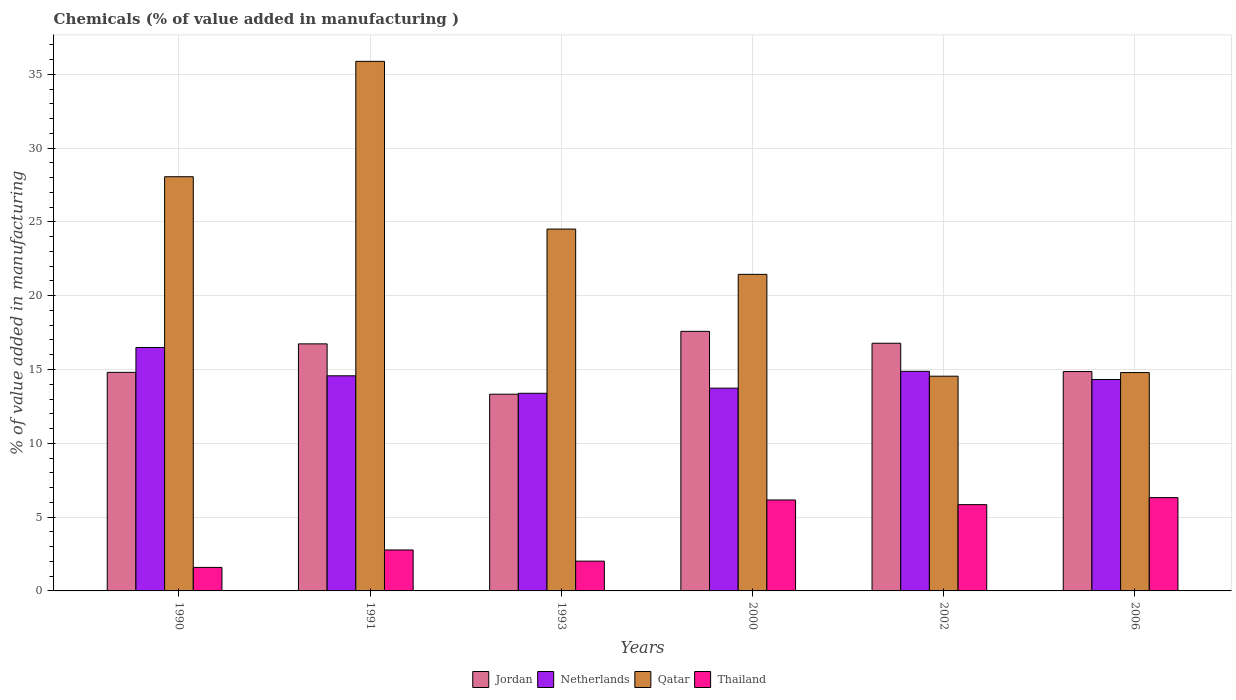How many different coloured bars are there?
Make the answer very short. 4. Are the number of bars per tick equal to the number of legend labels?
Provide a succinct answer. Yes. Are the number of bars on each tick of the X-axis equal?
Provide a succinct answer. Yes. How many bars are there on the 5th tick from the left?
Give a very brief answer. 4. What is the label of the 6th group of bars from the left?
Give a very brief answer. 2006. In how many cases, is the number of bars for a given year not equal to the number of legend labels?
Ensure brevity in your answer.  0. What is the value added in manufacturing chemicals in Netherlands in 1993?
Make the answer very short. 13.39. Across all years, what is the maximum value added in manufacturing chemicals in Jordan?
Offer a terse response. 17.58. Across all years, what is the minimum value added in manufacturing chemicals in Qatar?
Give a very brief answer. 14.55. In which year was the value added in manufacturing chemicals in Qatar minimum?
Provide a short and direct response. 2002. What is the total value added in manufacturing chemicals in Jordan in the graph?
Keep it short and to the point. 94.09. What is the difference between the value added in manufacturing chemicals in Thailand in 1991 and that in 2000?
Offer a very short reply. -3.39. What is the difference between the value added in manufacturing chemicals in Thailand in 1993 and the value added in manufacturing chemicals in Netherlands in 2002?
Give a very brief answer. -12.86. What is the average value added in manufacturing chemicals in Qatar per year?
Keep it short and to the point. 23.21. In the year 2002, what is the difference between the value added in manufacturing chemicals in Thailand and value added in manufacturing chemicals in Jordan?
Make the answer very short. -10.93. What is the ratio of the value added in manufacturing chemicals in Netherlands in 1991 to that in 1993?
Ensure brevity in your answer.  1.09. Is the difference between the value added in manufacturing chemicals in Thailand in 1990 and 2002 greater than the difference between the value added in manufacturing chemicals in Jordan in 1990 and 2002?
Your response must be concise. No. What is the difference between the highest and the second highest value added in manufacturing chemicals in Jordan?
Offer a terse response. 0.81. What is the difference between the highest and the lowest value added in manufacturing chemicals in Thailand?
Provide a short and direct response. 4.73. What does the 4th bar from the left in 2006 represents?
Your response must be concise. Thailand. What does the 2nd bar from the right in 2002 represents?
Provide a succinct answer. Qatar. Is it the case that in every year, the sum of the value added in manufacturing chemicals in Netherlands and value added in manufacturing chemicals in Jordan is greater than the value added in manufacturing chemicals in Thailand?
Ensure brevity in your answer.  Yes. How many years are there in the graph?
Your answer should be very brief. 6. What is the difference between two consecutive major ticks on the Y-axis?
Keep it short and to the point. 5. Are the values on the major ticks of Y-axis written in scientific E-notation?
Give a very brief answer. No. Where does the legend appear in the graph?
Your response must be concise. Bottom center. How many legend labels are there?
Provide a succinct answer. 4. How are the legend labels stacked?
Give a very brief answer. Horizontal. What is the title of the graph?
Give a very brief answer. Chemicals (% of value added in manufacturing ). Does "Mauritius" appear as one of the legend labels in the graph?
Offer a very short reply. No. What is the label or title of the Y-axis?
Provide a succinct answer. % of value added in manufacturing. What is the % of value added in manufacturing in Jordan in 1990?
Your answer should be very brief. 14.81. What is the % of value added in manufacturing in Netherlands in 1990?
Keep it short and to the point. 16.49. What is the % of value added in manufacturing of Qatar in 1990?
Provide a short and direct response. 28.06. What is the % of value added in manufacturing of Thailand in 1990?
Give a very brief answer. 1.59. What is the % of value added in manufacturing of Jordan in 1991?
Your answer should be very brief. 16.74. What is the % of value added in manufacturing of Netherlands in 1991?
Make the answer very short. 14.57. What is the % of value added in manufacturing in Qatar in 1991?
Your answer should be very brief. 35.88. What is the % of value added in manufacturing in Thailand in 1991?
Offer a very short reply. 2.77. What is the % of value added in manufacturing of Jordan in 1993?
Keep it short and to the point. 13.33. What is the % of value added in manufacturing of Netherlands in 1993?
Offer a very short reply. 13.39. What is the % of value added in manufacturing of Qatar in 1993?
Offer a terse response. 24.51. What is the % of value added in manufacturing in Thailand in 1993?
Your answer should be compact. 2.02. What is the % of value added in manufacturing in Jordan in 2000?
Give a very brief answer. 17.58. What is the % of value added in manufacturing of Netherlands in 2000?
Your response must be concise. 13.74. What is the % of value added in manufacturing of Qatar in 2000?
Keep it short and to the point. 21.45. What is the % of value added in manufacturing of Thailand in 2000?
Your answer should be very brief. 6.16. What is the % of value added in manufacturing of Jordan in 2002?
Offer a very short reply. 16.78. What is the % of value added in manufacturing of Netherlands in 2002?
Offer a terse response. 14.88. What is the % of value added in manufacturing in Qatar in 2002?
Your answer should be very brief. 14.55. What is the % of value added in manufacturing of Thailand in 2002?
Give a very brief answer. 5.85. What is the % of value added in manufacturing in Jordan in 2006?
Give a very brief answer. 14.86. What is the % of value added in manufacturing in Netherlands in 2006?
Ensure brevity in your answer.  14.32. What is the % of value added in manufacturing in Qatar in 2006?
Your answer should be compact. 14.79. What is the % of value added in manufacturing in Thailand in 2006?
Ensure brevity in your answer.  6.32. Across all years, what is the maximum % of value added in manufacturing in Jordan?
Make the answer very short. 17.58. Across all years, what is the maximum % of value added in manufacturing in Netherlands?
Your response must be concise. 16.49. Across all years, what is the maximum % of value added in manufacturing in Qatar?
Offer a terse response. 35.88. Across all years, what is the maximum % of value added in manufacturing of Thailand?
Ensure brevity in your answer.  6.32. Across all years, what is the minimum % of value added in manufacturing in Jordan?
Give a very brief answer. 13.33. Across all years, what is the minimum % of value added in manufacturing of Netherlands?
Offer a very short reply. 13.39. Across all years, what is the minimum % of value added in manufacturing in Qatar?
Ensure brevity in your answer.  14.55. Across all years, what is the minimum % of value added in manufacturing in Thailand?
Give a very brief answer. 1.59. What is the total % of value added in manufacturing of Jordan in the graph?
Make the answer very short. 94.09. What is the total % of value added in manufacturing of Netherlands in the graph?
Provide a succinct answer. 87.39. What is the total % of value added in manufacturing of Qatar in the graph?
Give a very brief answer. 139.23. What is the total % of value added in manufacturing in Thailand in the graph?
Your answer should be compact. 24.71. What is the difference between the % of value added in manufacturing of Jordan in 1990 and that in 1991?
Your response must be concise. -1.93. What is the difference between the % of value added in manufacturing of Netherlands in 1990 and that in 1991?
Offer a terse response. 1.92. What is the difference between the % of value added in manufacturing in Qatar in 1990 and that in 1991?
Keep it short and to the point. -7.82. What is the difference between the % of value added in manufacturing of Thailand in 1990 and that in 1991?
Offer a terse response. -1.18. What is the difference between the % of value added in manufacturing of Jordan in 1990 and that in 1993?
Your answer should be very brief. 1.48. What is the difference between the % of value added in manufacturing of Netherlands in 1990 and that in 1993?
Provide a succinct answer. 3.1. What is the difference between the % of value added in manufacturing of Qatar in 1990 and that in 1993?
Give a very brief answer. 3.55. What is the difference between the % of value added in manufacturing of Thailand in 1990 and that in 1993?
Offer a terse response. -0.42. What is the difference between the % of value added in manufacturing in Jordan in 1990 and that in 2000?
Keep it short and to the point. -2.78. What is the difference between the % of value added in manufacturing of Netherlands in 1990 and that in 2000?
Keep it short and to the point. 2.75. What is the difference between the % of value added in manufacturing in Qatar in 1990 and that in 2000?
Offer a terse response. 6.61. What is the difference between the % of value added in manufacturing in Thailand in 1990 and that in 2000?
Offer a very short reply. -4.57. What is the difference between the % of value added in manufacturing in Jordan in 1990 and that in 2002?
Provide a succinct answer. -1.97. What is the difference between the % of value added in manufacturing of Netherlands in 1990 and that in 2002?
Offer a very short reply. 1.61. What is the difference between the % of value added in manufacturing in Qatar in 1990 and that in 2002?
Make the answer very short. 13.51. What is the difference between the % of value added in manufacturing of Thailand in 1990 and that in 2002?
Offer a very short reply. -4.25. What is the difference between the % of value added in manufacturing of Jordan in 1990 and that in 2006?
Give a very brief answer. -0.05. What is the difference between the % of value added in manufacturing of Netherlands in 1990 and that in 2006?
Provide a short and direct response. 2.17. What is the difference between the % of value added in manufacturing of Qatar in 1990 and that in 2006?
Your response must be concise. 13.27. What is the difference between the % of value added in manufacturing of Thailand in 1990 and that in 2006?
Your response must be concise. -4.73. What is the difference between the % of value added in manufacturing in Jordan in 1991 and that in 1993?
Give a very brief answer. 3.41. What is the difference between the % of value added in manufacturing in Netherlands in 1991 and that in 1993?
Your answer should be very brief. 1.19. What is the difference between the % of value added in manufacturing in Qatar in 1991 and that in 1993?
Your response must be concise. 11.36. What is the difference between the % of value added in manufacturing of Thailand in 1991 and that in 1993?
Make the answer very short. 0.76. What is the difference between the % of value added in manufacturing of Jordan in 1991 and that in 2000?
Your response must be concise. -0.85. What is the difference between the % of value added in manufacturing in Netherlands in 1991 and that in 2000?
Ensure brevity in your answer.  0.84. What is the difference between the % of value added in manufacturing in Qatar in 1991 and that in 2000?
Give a very brief answer. 14.43. What is the difference between the % of value added in manufacturing in Thailand in 1991 and that in 2000?
Provide a short and direct response. -3.39. What is the difference between the % of value added in manufacturing of Jordan in 1991 and that in 2002?
Offer a very short reply. -0.04. What is the difference between the % of value added in manufacturing of Netherlands in 1991 and that in 2002?
Ensure brevity in your answer.  -0.3. What is the difference between the % of value added in manufacturing of Qatar in 1991 and that in 2002?
Make the answer very short. 21.33. What is the difference between the % of value added in manufacturing of Thailand in 1991 and that in 2002?
Offer a very short reply. -3.07. What is the difference between the % of value added in manufacturing in Jordan in 1991 and that in 2006?
Give a very brief answer. 1.88. What is the difference between the % of value added in manufacturing of Netherlands in 1991 and that in 2006?
Keep it short and to the point. 0.25. What is the difference between the % of value added in manufacturing of Qatar in 1991 and that in 2006?
Offer a very short reply. 21.08. What is the difference between the % of value added in manufacturing in Thailand in 1991 and that in 2006?
Provide a succinct answer. -3.55. What is the difference between the % of value added in manufacturing of Jordan in 1993 and that in 2000?
Your response must be concise. -4.26. What is the difference between the % of value added in manufacturing in Netherlands in 1993 and that in 2000?
Your answer should be very brief. -0.35. What is the difference between the % of value added in manufacturing of Qatar in 1993 and that in 2000?
Your answer should be very brief. 3.07. What is the difference between the % of value added in manufacturing in Thailand in 1993 and that in 2000?
Keep it short and to the point. -4.14. What is the difference between the % of value added in manufacturing in Jordan in 1993 and that in 2002?
Offer a terse response. -3.45. What is the difference between the % of value added in manufacturing of Netherlands in 1993 and that in 2002?
Offer a terse response. -1.49. What is the difference between the % of value added in manufacturing in Qatar in 1993 and that in 2002?
Your answer should be very brief. 9.97. What is the difference between the % of value added in manufacturing of Thailand in 1993 and that in 2002?
Your answer should be very brief. -3.83. What is the difference between the % of value added in manufacturing in Jordan in 1993 and that in 2006?
Give a very brief answer. -1.54. What is the difference between the % of value added in manufacturing in Netherlands in 1993 and that in 2006?
Your answer should be compact. -0.93. What is the difference between the % of value added in manufacturing of Qatar in 1993 and that in 2006?
Your response must be concise. 9.72. What is the difference between the % of value added in manufacturing in Thailand in 1993 and that in 2006?
Ensure brevity in your answer.  -4.3. What is the difference between the % of value added in manufacturing in Jordan in 2000 and that in 2002?
Ensure brevity in your answer.  0.81. What is the difference between the % of value added in manufacturing of Netherlands in 2000 and that in 2002?
Give a very brief answer. -1.14. What is the difference between the % of value added in manufacturing in Qatar in 2000 and that in 2002?
Your answer should be very brief. 6.9. What is the difference between the % of value added in manufacturing in Thailand in 2000 and that in 2002?
Provide a short and direct response. 0.31. What is the difference between the % of value added in manufacturing of Jordan in 2000 and that in 2006?
Offer a very short reply. 2.72. What is the difference between the % of value added in manufacturing in Netherlands in 2000 and that in 2006?
Provide a succinct answer. -0.59. What is the difference between the % of value added in manufacturing of Qatar in 2000 and that in 2006?
Provide a short and direct response. 6.65. What is the difference between the % of value added in manufacturing of Thailand in 2000 and that in 2006?
Your answer should be very brief. -0.16. What is the difference between the % of value added in manufacturing in Jordan in 2002 and that in 2006?
Offer a terse response. 1.92. What is the difference between the % of value added in manufacturing in Netherlands in 2002 and that in 2006?
Ensure brevity in your answer.  0.56. What is the difference between the % of value added in manufacturing in Qatar in 2002 and that in 2006?
Your response must be concise. -0.25. What is the difference between the % of value added in manufacturing of Thailand in 2002 and that in 2006?
Offer a very short reply. -0.47. What is the difference between the % of value added in manufacturing in Jordan in 1990 and the % of value added in manufacturing in Netherlands in 1991?
Ensure brevity in your answer.  0.23. What is the difference between the % of value added in manufacturing of Jordan in 1990 and the % of value added in manufacturing of Qatar in 1991?
Your response must be concise. -21.07. What is the difference between the % of value added in manufacturing in Jordan in 1990 and the % of value added in manufacturing in Thailand in 1991?
Provide a succinct answer. 12.03. What is the difference between the % of value added in manufacturing in Netherlands in 1990 and the % of value added in manufacturing in Qatar in 1991?
Give a very brief answer. -19.38. What is the difference between the % of value added in manufacturing of Netherlands in 1990 and the % of value added in manufacturing of Thailand in 1991?
Ensure brevity in your answer.  13.72. What is the difference between the % of value added in manufacturing in Qatar in 1990 and the % of value added in manufacturing in Thailand in 1991?
Offer a very short reply. 25.28. What is the difference between the % of value added in manufacturing in Jordan in 1990 and the % of value added in manufacturing in Netherlands in 1993?
Offer a very short reply. 1.42. What is the difference between the % of value added in manufacturing of Jordan in 1990 and the % of value added in manufacturing of Qatar in 1993?
Provide a short and direct response. -9.71. What is the difference between the % of value added in manufacturing of Jordan in 1990 and the % of value added in manufacturing of Thailand in 1993?
Offer a very short reply. 12.79. What is the difference between the % of value added in manufacturing in Netherlands in 1990 and the % of value added in manufacturing in Qatar in 1993?
Ensure brevity in your answer.  -8.02. What is the difference between the % of value added in manufacturing in Netherlands in 1990 and the % of value added in manufacturing in Thailand in 1993?
Provide a succinct answer. 14.47. What is the difference between the % of value added in manufacturing in Qatar in 1990 and the % of value added in manufacturing in Thailand in 1993?
Provide a succinct answer. 26.04. What is the difference between the % of value added in manufacturing of Jordan in 1990 and the % of value added in manufacturing of Netherlands in 2000?
Make the answer very short. 1.07. What is the difference between the % of value added in manufacturing of Jordan in 1990 and the % of value added in manufacturing of Qatar in 2000?
Make the answer very short. -6.64. What is the difference between the % of value added in manufacturing of Jordan in 1990 and the % of value added in manufacturing of Thailand in 2000?
Offer a very short reply. 8.65. What is the difference between the % of value added in manufacturing of Netherlands in 1990 and the % of value added in manufacturing of Qatar in 2000?
Your answer should be very brief. -4.96. What is the difference between the % of value added in manufacturing of Netherlands in 1990 and the % of value added in manufacturing of Thailand in 2000?
Make the answer very short. 10.33. What is the difference between the % of value added in manufacturing of Qatar in 1990 and the % of value added in manufacturing of Thailand in 2000?
Provide a succinct answer. 21.9. What is the difference between the % of value added in manufacturing of Jordan in 1990 and the % of value added in manufacturing of Netherlands in 2002?
Ensure brevity in your answer.  -0.07. What is the difference between the % of value added in manufacturing of Jordan in 1990 and the % of value added in manufacturing of Qatar in 2002?
Provide a short and direct response. 0.26. What is the difference between the % of value added in manufacturing of Jordan in 1990 and the % of value added in manufacturing of Thailand in 2002?
Provide a succinct answer. 8.96. What is the difference between the % of value added in manufacturing in Netherlands in 1990 and the % of value added in manufacturing in Qatar in 2002?
Provide a short and direct response. 1.94. What is the difference between the % of value added in manufacturing of Netherlands in 1990 and the % of value added in manufacturing of Thailand in 2002?
Offer a very short reply. 10.64. What is the difference between the % of value added in manufacturing of Qatar in 1990 and the % of value added in manufacturing of Thailand in 2002?
Make the answer very short. 22.21. What is the difference between the % of value added in manufacturing of Jordan in 1990 and the % of value added in manufacturing of Netherlands in 2006?
Give a very brief answer. 0.49. What is the difference between the % of value added in manufacturing in Jordan in 1990 and the % of value added in manufacturing in Qatar in 2006?
Your answer should be very brief. 0.02. What is the difference between the % of value added in manufacturing of Jordan in 1990 and the % of value added in manufacturing of Thailand in 2006?
Ensure brevity in your answer.  8.49. What is the difference between the % of value added in manufacturing of Netherlands in 1990 and the % of value added in manufacturing of Qatar in 2006?
Provide a succinct answer. 1.7. What is the difference between the % of value added in manufacturing of Netherlands in 1990 and the % of value added in manufacturing of Thailand in 2006?
Ensure brevity in your answer.  10.17. What is the difference between the % of value added in manufacturing in Qatar in 1990 and the % of value added in manufacturing in Thailand in 2006?
Ensure brevity in your answer.  21.74. What is the difference between the % of value added in manufacturing of Jordan in 1991 and the % of value added in manufacturing of Netherlands in 1993?
Your answer should be compact. 3.35. What is the difference between the % of value added in manufacturing of Jordan in 1991 and the % of value added in manufacturing of Qatar in 1993?
Provide a short and direct response. -7.78. What is the difference between the % of value added in manufacturing of Jordan in 1991 and the % of value added in manufacturing of Thailand in 1993?
Provide a short and direct response. 14.72. What is the difference between the % of value added in manufacturing in Netherlands in 1991 and the % of value added in manufacturing in Qatar in 1993?
Offer a very short reply. -9.94. What is the difference between the % of value added in manufacturing of Netherlands in 1991 and the % of value added in manufacturing of Thailand in 1993?
Your answer should be compact. 12.55. What is the difference between the % of value added in manufacturing in Qatar in 1991 and the % of value added in manufacturing in Thailand in 1993?
Provide a short and direct response. 33.86. What is the difference between the % of value added in manufacturing in Jordan in 1991 and the % of value added in manufacturing in Netherlands in 2000?
Provide a short and direct response. 3. What is the difference between the % of value added in manufacturing in Jordan in 1991 and the % of value added in manufacturing in Qatar in 2000?
Ensure brevity in your answer.  -4.71. What is the difference between the % of value added in manufacturing of Jordan in 1991 and the % of value added in manufacturing of Thailand in 2000?
Offer a very short reply. 10.58. What is the difference between the % of value added in manufacturing of Netherlands in 1991 and the % of value added in manufacturing of Qatar in 2000?
Offer a very short reply. -6.87. What is the difference between the % of value added in manufacturing in Netherlands in 1991 and the % of value added in manufacturing in Thailand in 2000?
Your answer should be compact. 8.41. What is the difference between the % of value added in manufacturing in Qatar in 1991 and the % of value added in manufacturing in Thailand in 2000?
Provide a succinct answer. 29.71. What is the difference between the % of value added in manufacturing of Jordan in 1991 and the % of value added in manufacturing of Netherlands in 2002?
Make the answer very short. 1.86. What is the difference between the % of value added in manufacturing in Jordan in 1991 and the % of value added in manufacturing in Qatar in 2002?
Your response must be concise. 2.19. What is the difference between the % of value added in manufacturing in Jordan in 1991 and the % of value added in manufacturing in Thailand in 2002?
Offer a very short reply. 10.89. What is the difference between the % of value added in manufacturing of Netherlands in 1991 and the % of value added in manufacturing of Qatar in 2002?
Offer a very short reply. 0.03. What is the difference between the % of value added in manufacturing of Netherlands in 1991 and the % of value added in manufacturing of Thailand in 2002?
Your answer should be compact. 8.73. What is the difference between the % of value added in manufacturing of Qatar in 1991 and the % of value added in manufacturing of Thailand in 2002?
Offer a terse response. 30.03. What is the difference between the % of value added in manufacturing in Jordan in 1991 and the % of value added in manufacturing in Netherlands in 2006?
Ensure brevity in your answer.  2.42. What is the difference between the % of value added in manufacturing in Jordan in 1991 and the % of value added in manufacturing in Qatar in 2006?
Your response must be concise. 1.94. What is the difference between the % of value added in manufacturing in Jordan in 1991 and the % of value added in manufacturing in Thailand in 2006?
Your response must be concise. 10.42. What is the difference between the % of value added in manufacturing of Netherlands in 1991 and the % of value added in manufacturing of Qatar in 2006?
Provide a succinct answer. -0.22. What is the difference between the % of value added in manufacturing in Netherlands in 1991 and the % of value added in manufacturing in Thailand in 2006?
Your answer should be compact. 8.25. What is the difference between the % of value added in manufacturing in Qatar in 1991 and the % of value added in manufacturing in Thailand in 2006?
Your answer should be very brief. 29.55. What is the difference between the % of value added in manufacturing in Jordan in 1993 and the % of value added in manufacturing in Netherlands in 2000?
Ensure brevity in your answer.  -0.41. What is the difference between the % of value added in manufacturing of Jordan in 1993 and the % of value added in manufacturing of Qatar in 2000?
Give a very brief answer. -8.12. What is the difference between the % of value added in manufacturing in Jordan in 1993 and the % of value added in manufacturing in Thailand in 2000?
Offer a very short reply. 7.17. What is the difference between the % of value added in manufacturing of Netherlands in 1993 and the % of value added in manufacturing of Qatar in 2000?
Ensure brevity in your answer.  -8.06. What is the difference between the % of value added in manufacturing of Netherlands in 1993 and the % of value added in manufacturing of Thailand in 2000?
Give a very brief answer. 7.23. What is the difference between the % of value added in manufacturing in Qatar in 1993 and the % of value added in manufacturing in Thailand in 2000?
Make the answer very short. 18.35. What is the difference between the % of value added in manufacturing in Jordan in 1993 and the % of value added in manufacturing in Netherlands in 2002?
Offer a very short reply. -1.55. What is the difference between the % of value added in manufacturing in Jordan in 1993 and the % of value added in manufacturing in Qatar in 2002?
Keep it short and to the point. -1.22. What is the difference between the % of value added in manufacturing of Jordan in 1993 and the % of value added in manufacturing of Thailand in 2002?
Provide a succinct answer. 7.48. What is the difference between the % of value added in manufacturing in Netherlands in 1993 and the % of value added in manufacturing in Qatar in 2002?
Provide a short and direct response. -1.16. What is the difference between the % of value added in manufacturing of Netherlands in 1993 and the % of value added in manufacturing of Thailand in 2002?
Your response must be concise. 7.54. What is the difference between the % of value added in manufacturing of Qatar in 1993 and the % of value added in manufacturing of Thailand in 2002?
Provide a succinct answer. 18.67. What is the difference between the % of value added in manufacturing of Jordan in 1993 and the % of value added in manufacturing of Netherlands in 2006?
Offer a terse response. -1. What is the difference between the % of value added in manufacturing in Jordan in 1993 and the % of value added in manufacturing in Qatar in 2006?
Give a very brief answer. -1.47. What is the difference between the % of value added in manufacturing in Jordan in 1993 and the % of value added in manufacturing in Thailand in 2006?
Provide a succinct answer. 7. What is the difference between the % of value added in manufacturing in Netherlands in 1993 and the % of value added in manufacturing in Qatar in 2006?
Your answer should be compact. -1.4. What is the difference between the % of value added in manufacturing in Netherlands in 1993 and the % of value added in manufacturing in Thailand in 2006?
Ensure brevity in your answer.  7.07. What is the difference between the % of value added in manufacturing of Qatar in 1993 and the % of value added in manufacturing of Thailand in 2006?
Your answer should be compact. 18.19. What is the difference between the % of value added in manufacturing in Jordan in 2000 and the % of value added in manufacturing in Netherlands in 2002?
Give a very brief answer. 2.71. What is the difference between the % of value added in manufacturing in Jordan in 2000 and the % of value added in manufacturing in Qatar in 2002?
Give a very brief answer. 3.04. What is the difference between the % of value added in manufacturing in Jordan in 2000 and the % of value added in manufacturing in Thailand in 2002?
Your answer should be compact. 11.74. What is the difference between the % of value added in manufacturing of Netherlands in 2000 and the % of value added in manufacturing of Qatar in 2002?
Your answer should be compact. -0.81. What is the difference between the % of value added in manufacturing of Netherlands in 2000 and the % of value added in manufacturing of Thailand in 2002?
Your response must be concise. 7.89. What is the difference between the % of value added in manufacturing of Qatar in 2000 and the % of value added in manufacturing of Thailand in 2002?
Your answer should be compact. 15.6. What is the difference between the % of value added in manufacturing in Jordan in 2000 and the % of value added in manufacturing in Netherlands in 2006?
Ensure brevity in your answer.  3.26. What is the difference between the % of value added in manufacturing in Jordan in 2000 and the % of value added in manufacturing in Qatar in 2006?
Give a very brief answer. 2.79. What is the difference between the % of value added in manufacturing of Jordan in 2000 and the % of value added in manufacturing of Thailand in 2006?
Give a very brief answer. 11.26. What is the difference between the % of value added in manufacturing of Netherlands in 2000 and the % of value added in manufacturing of Qatar in 2006?
Your answer should be compact. -1.06. What is the difference between the % of value added in manufacturing in Netherlands in 2000 and the % of value added in manufacturing in Thailand in 2006?
Your answer should be compact. 7.41. What is the difference between the % of value added in manufacturing of Qatar in 2000 and the % of value added in manufacturing of Thailand in 2006?
Your answer should be very brief. 15.12. What is the difference between the % of value added in manufacturing of Jordan in 2002 and the % of value added in manufacturing of Netherlands in 2006?
Offer a very short reply. 2.46. What is the difference between the % of value added in manufacturing in Jordan in 2002 and the % of value added in manufacturing in Qatar in 2006?
Offer a very short reply. 1.99. What is the difference between the % of value added in manufacturing in Jordan in 2002 and the % of value added in manufacturing in Thailand in 2006?
Keep it short and to the point. 10.46. What is the difference between the % of value added in manufacturing in Netherlands in 2002 and the % of value added in manufacturing in Qatar in 2006?
Your answer should be very brief. 0.09. What is the difference between the % of value added in manufacturing of Netherlands in 2002 and the % of value added in manufacturing of Thailand in 2006?
Ensure brevity in your answer.  8.56. What is the difference between the % of value added in manufacturing in Qatar in 2002 and the % of value added in manufacturing in Thailand in 2006?
Provide a succinct answer. 8.23. What is the average % of value added in manufacturing in Jordan per year?
Your answer should be very brief. 15.68. What is the average % of value added in manufacturing in Netherlands per year?
Offer a very short reply. 14.56. What is the average % of value added in manufacturing of Qatar per year?
Offer a terse response. 23.21. What is the average % of value added in manufacturing of Thailand per year?
Give a very brief answer. 4.12. In the year 1990, what is the difference between the % of value added in manufacturing of Jordan and % of value added in manufacturing of Netherlands?
Offer a very short reply. -1.68. In the year 1990, what is the difference between the % of value added in manufacturing of Jordan and % of value added in manufacturing of Qatar?
Keep it short and to the point. -13.25. In the year 1990, what is the difference between the % of value added in manufacturing in Jordan and % of value added in manufacturing in Thailand?
Make the answer very short. 13.21. In the year 1990, what is the difference between the % of value added in manufacturing of Netherlands and % of value added in manufacturing of Qatar?
Ensure brevity in your answer.  -11.57. In the year 1990, what is the difference between the % of value added in manufacturing in Netherlands and % of value added in manufacturing in Thailand?
Give a very brief answer. 14.9. In the year 1990, what is the difference between the % of value added in manufacturing in Qatar and % of value added in manufacturing in Thailand?
Ensure brevity in your answer.  26.47. In the year 1991, what is the difference between the % of value added in manufacturing of Jordan and % of value added in manufacturing of Netherlands?
Provide a short and direct response. 2.16. In the year 1991, what is the difference between the % of value added in manufacturing of Jordan and % of value added in manufacturing of Qatar?
Provide a short and direct response. -19.14. In the year 1991, what is the difference between the % of value added in manufacturing in Jordan and % of value added in manufacturing in Thailand?
Offer a terse response. 13.96. In the year 1991, what is the difference between the % of value added in manufacturing of Netherlands and % of value added in manufacturing of Qatar?
Provide a short and direct response. -21.3. In the year 1991, what is the difference between the % of value added in manufacturing of Netherlands and % of value added in manufacturing of Thailand?
Provide a succinct answer. 11.8. In the year 1991, what is the difference between the % of value added in manufacturing in Qatar and % of value added in manufacturing in Thailand?
Provide a short and direct response. 33.1. In the year 1993, what is the difference between the % of value added in manufacturing of Jordan and % of value added in manufacturing of Netherlands?
Your answer should be very brief. -0.06. In the year 1993, what is the difference between the % of value added in manufacturing in Jordan and % of value added in manufacturing in Qatar?
Offer a very short reply. -11.19. In the year 1993, what is the difference between the % of value added in manufacturing in Jordan and % of value added in manufacturing in Thailand?
Your answer should be very brief. 11.31. In the year 1993, what is the difference between the % of value added in manufacturing in Netherlands and % of value added in manufacturing in Qatar?
Offer a terse response. -11.12. In the year 1993, what is the difference between the % of value added in manufacturing of Netherlands and % of value added in manufacturing of Thailand?
Give a very brief answer. 11.37. In the year 1993, what is the difference between the % of value added in manufacturing of Qatar and % of value added in manufacturing of Thailand?
Keep it short and to the point. 22.49. In the year 2000, what is the difference between the % of value added in manufacturing of Jordan and % of value added in manufacturing of Netherlands?
Your answer should be very brief. 3.85. In the year 2000, what is the difference between the % of value added in manufacturing in Jordan and % of value added in manufacturing in Qatar?
Offer a terse response. -3.86. In the year 2000, what is the difference between the % of value added in manufacturing in Jordan and % of value added in manufacturing in Thailand?
Give a very brief answer. 11.42. In the year 2000, what is the difference between the % of value added in manufacturing of Netherlands and % of value added in manufacturing of Qatar?
Give a very brief answer. -7.71. In the year 2000, what is the difference between the % of value added in manufacturing of Netherlands and % of value added in manufacturing of Thailand?
Provide a short and direct response. 7.57. In the year 2000, what is the difference between the % of value added in manufacturing of Qatar and % of value added in manufacturing of Thailand?
Offer a terse response. 15.29. In the year 2002, what is the difference between the % of value added in manufacturing in Jordan and % of value added in manufacturing in Netherlands?
Offer a very short reply. 1.9. In the year 2002, what is the difference between the % of value added in manufacturing in Jordan and % of value added in manufacturing in Qatar?
Your answer should be very brief. 2.23. In the year 2002, what is the difference between the % of value added in manufacturing of Jordan and % of value added in manufacturing of Thailand?
Your answer should be very brief. 10.93. In the year 2002, what is the difference between the % of value added in manufacturing in Netherlands and % of value added in manufacturing in Qatar?
Your answer should be very brief. 0.33. In the year 2002, what is the difference between the % of value added in manufacturing of Netherlands and % of value added in manufacturing of Thailand?
Your answer should be very brief. 9.03. In the year 2006, what is the difference between the % of value added in manufacturing in Jordan and % of value added in manufacturing in Netherlands?
Provide a short and direct response. 0.54. In the year 2006, what is the difference between the % of value added in manufacturing in Jordan and % of value added in manufacturing in Qatar?
Provide a succinct answer. 0.07. In the year 2006, what is the difference between the % of value added in manufacturing in Jordan and % of value added in manufacturing in Thailand?
Your answer should be compact. 8.54. In the year 2006, what is the difference between the % of value added in manufacturing in Netherlands and % of value added in manufacturing in Qatar?
Your answer should be compact. -0.47. In the year 2006, what is the difference between the % of value added in manufacturing in Netherlands and % of value added in manufacturing in Thailand?
Keep it short and to the point. 8. In the year 2006, what is the difference between the % of value added in manufacturing of Qatar and % of value added in manufacturing of Thailand?
Offer a very short reply. 8.47. What is the ratio of the % of value added in manufacturing in Jordan in 1990 to that in 1991?
Provide a succinct answer. 0.88. What is the ratio of the % of value added in manufacturing of Netherlands in 1990 to that in 1991?
Your response must be concise. 1.13. What is the ratio of the % of value added in manufacturing in Qatar in 1990 to that in 1991?
Keep it short and to the point. 0.78. What is the ratio of the % of value added in manufacturing of Thailand in 1990 to that in 1991?
Offer a very short reply. 0.57. What is the ratio of the % of value added in manufacturing in Jordan in 1990 to that in 1993?
Offer a terse response. 1.11. What is the ratio of the % of value added in manufacturing of Netherlands in 1990 to that in 1993?
Your answer should be very brief. 1.23. What is the ratio of the % of value added in manufacturing in Qatar in 1990 to that in 1993?
Your answer should be very brief. 1.14. What is the ratio of the % of value added in manufacturing in Thailand in 1990 to that in 1993?
Your answer should be compact. 0.79. What is the ratio of the % of value added in manufacturing in Jordan in 1990 to that in 2000?
Your response must be concise. 0.84. What is the ratio of the % of value added in manufacturing in Netherlands in 1990 to that in 2000?
Your answer should be compact. 1.2. What is the ratio of the % of value added in manufacturing of Qatar in 1990 to that in 2000?
Ensure brevity in your answer.  1.31. What is the ratio of the % of value added in manufacturing of Thailand in 1990 to that in 2000?
Give a very brief answer. 0.26. What is the ratio of the % of value added in manufacturing in Jordan in 1990 to that in 2002?
Provide a succinct answer. 0.88. What is the ratio of the % of value added in manufacturing of Netherlands in 1990 to that in 2002?
Give a very brief answer. 1.11. What is the ratio of the % of value added in manufacturing in Qatar in 1990 to that in 2002?
Offer a terse response. 1.93. What is the ratio of the % of value added in manufacturing in Thailand in 1990 to that in 2002?
Your answer should be very brief. 0.27. What is the ratio of the % of value added in manufacturing in Jordan in 1990 to that in 2006?
Keep it short and to the point. 1. What is the ratio of the % of value added in manufacturing in Netherlands in 1990 to that in 2006?
Your answer should be compact. 1.15. What is the ratio of the % of value added in manufacturing of Qatar in 1990 to that in 2006?
Make the answer very short. 1.9. What is the ratio of the % of value added in manufacturing in Thailand in 1990 to that in 2006?
Ensure brevity in your answer.  0.25. What is the ratio of the % of value added in manufacturing of Jordan in 1991 to that in 1993?
Ensure brevity in your answer.  1.26. What is the ratio of the % of value added in manufacturing of Netherlands in 1991 to that in 1993?
Provide a succinct answer. 1.09. What is the ratio of the % of value added in manufacturing in Qatar in 1991 to that in 1993?
Make the answer very short. 1.46. What is the ratio of the % of value added in manufacturing of Thailand in 1991 to that in 1993?
Give a very brief answer. 1.37. What is the ratio of the % of value added in manufacturing in Jordan in 1991 to that in 2000?
Offer a very short reply. 0.95. What is the ratio of the % of value added in manufacturing in Netherlands in 1991 to that in 2000?
Your answer should be compact. 1.06. What is the ratio of the % of value added in manufacturing of Qatar in 1991 to that in 2000?
Make the answer very short. 1.67. What is the ratio of the % of value added in manufacturing of Thailand in 1991 to that in 2000?
Keep it short and to the point. 0.45. What is the ratio of the % of value added in manufacturing of Netherlands in 1991 to that in 2002?
Ensure brevity in your answer.  0.98. What is the ratio of the % of value added in manufacturing in Qatar in 1991 to that in 2002?
Offer a terse response. 2.47. What is the ratio of the % of value added in manufacturing of Thailand in 1991 to that in 2002?
Keep it short and to the point. 0.47. What is the ratio of the % of value added in manufacturing of Jordan in 1991 to that in 2006?
Your answer should be very brief. 1.13. What is the ratio of the % of value added in manufacturing in Netherlands in 1991 to that in 2006?
Give a very brief answer. 1.02. What is the ratio of the % of value added in manufacturing in Qatar in 1991 to that in 2006?
Your response must be concise. 2.43. What is the ratio of the % of value added in manufacturing of Thailand in 1991 to that in 2006?
Provide a short and direct response. 0.44. What is the ratio of the % of value added in manufacturing of Jordan in 1993 to that in 2000?
Ensure brevity in your answer.  0.76. What is the ratio of the % of value added in manufacturing in Netherlands in 1993 to that in 2000?
Give a very brief answer. 0.97. What is the ratio of the % of value added in manufacturing of Qatar in 1993 to that in 2000?
Give a very brief answer. 1.14. What is the ratio of the % of value added in manufacturing of Thailand in 1993 to that in 2000?
Provide a short and direct response. 0.33. What is the ratio of the % of value added in manufacturing in Jordan in 1993 to that in 2002?
Make the answer very short. 0.79. What is the ratio of the % of value added in manufacturing in Netherlands in 1993 to that in 2002?
Your response must be concise. 0.9. What is the ratio of the % of value added in manufacturing in Qatar in 1993 to that in 2002?
Offer a terse response. 1.69. What is the ratio of the % of value added in manufacturing in Thailand in 1993 to that in 2002?
Make the answer very short. 0.35. What is the ratio of the % of value added in manufacturing of Jordan in 1993 to that in 2006?
Provide a succinct answer. 0.9. What is the ratio of the % of value added in manufacturing of Netherlands in 1993 to that in 2006?
Provide a short and direct response. 0.93. What is the ratio of the % of value added in manufacturing of Qatar in 1993 to that in 2006?
Provide a short and direct response. 1.66. What is the ratio of the % of value added in manufacturing of Thailand in 1993 to that in 2006?
Keep it short and to the point. 0.32. What is the ratio of the % of value added in manufacturing in Jordan in 2000 to that in 2002?
Provide a short and direct response. 1.05. What is the ratio of the % of value added in manufacturing of Netherlands in 2000 to that in 2002?
Offer a very short reply. 0.92. What is the ratio of the % of value added in manufacturing in Qatar in 2000 to that in 2002?
Provide a succinct answer. 1.47. What is the ratio of the % of value added in manufacturing in Thailand in 2000 to that in 2002?
Give a very brief answer. 1.05. What is the ratio of the % of value added in manufacturing of Jordan in 2000 to that in 2006?
Your answer should be compact. 1.18. What is the ratio of the % of value added in manufacturing of Netherlands in 2000 to that in 2006?
Make the answer very short. 0.96. What is the ratio of the % of value added in manufacturing in Qatar in 2000 to that in 2006?
Make the answer very short. 1.45. What is the ratio of the % of value added in manufacturing in Thailand in 2000 to that in 2006?
Offer a very short reply. 0.97. What is the ratio of the % of value added in manufacturing in Jordan in 2002 to that in 2006?
Offer a terse response. 1.13. What is the ratio of the % of value added in manufacturing in Netherlands in 2002 to that in 2006?
Make the answer very short. 1.04. What is the ratio of the % of value added in manufacturing in Qatar in 2002 to that in 2006?
Offer a very short reply. 0.98. What is the ratio of the % of value added in manufacturing of Thailand in 2002 to that in 2006?
Ensure brevity in your answer.  0.92. What is the difference between the highest and the second highest % of value added in manufacturing in Jordan?
Offer a terse response. 0.81. What is the difference between the highest and the second highest % of value added in manufacturing of Netherlands?
Provide a short and direct response. 1.61. What is the difference between the highest and the second highest % of value added in manufacturing in Qatar?
Ensure brevity in your answer.  7.82. What is the difference between the highest and the second highest % of value added in manufacturing in Thailand?
Your response must be concise. 0.16. What is the difference between the highest and the lowest % of value added in manufacturing of Jordan?
Give a very brief answer. 4.26. What is the difference between the highest and the lowest % of value added in manufacturing of Netherlands?
Offer a very short reply. 3.1. What is the difference between the highest and the lowest % of value added in manufacturing in Qatar?
Keep it short and to the point. 21.33. What is the difference between the highest and the lowest % of value added in manufacturing in Thailand?
Offer a very short reply. 4.73. 